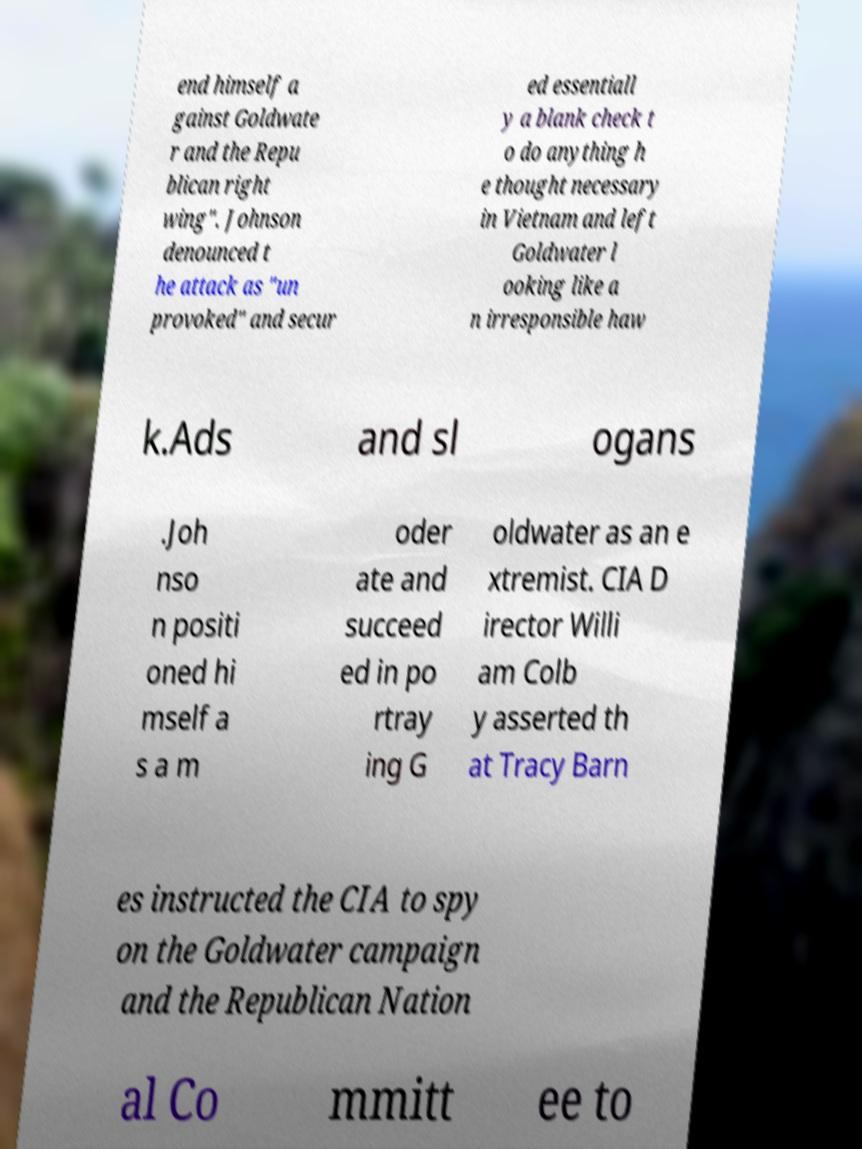What messages or text are displayed in this image? I need them in a readable, typed format. end himself a gainst Goldwate r and the Repu blican right wing". Johnson denounced t he attack as "un provoked" and secur ed essentiall y a blank check t o do anything h e thought necessary in Vietnam and left Goldwater l ooking like a n irresponsible haw k.Ads and sl ogans .Joh nso n positi oned hi mself a s a m oder ate and succeed ed in po rtray ing G oldwater as an e xtremist. CIA D irector Willi am Colb y asserted th at Tracy Barn es instructed the CIA to spy on the Goldwater campaign and the Republican Nation al Co mmitt ee to 